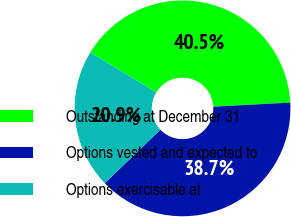<chart> <loc_0><loc_0><loc_500><loc_500><pie_chart><fcel>Outstanding at December 31<fcel>Options vested and expected to<fcel>Options exercisable at<nl><fcel>40.47%<fcel>38.66%<fcel>20.86%<nl></chart> 